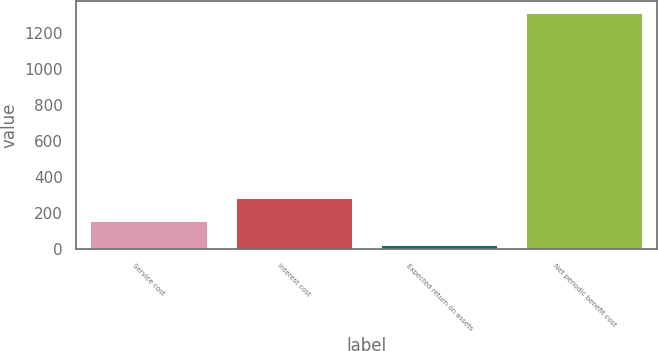<chart> <loc_0><loc_0><loc_500><loc_500><bar_chart><fcel>Service cost<fcel>Interest cost<fcel>Expected return on assets<fcel>Net periodic benefit cost<nl><fcel>153.7<fcel>282.4<fcel>25<fcel>1312<nl></chart> 